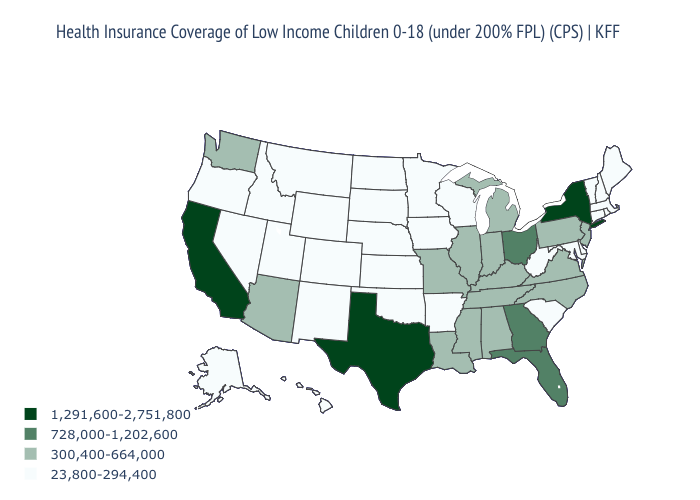Is the legend a continuous bar?
Give a very brief answer. No. What is the value of Wyoming?
Answer briefly. 23,800-294,400. Does Texas have the highest value in the South?
Answer briefly. Yes. Does Texas have the lowest value in the USA?
Concise answer only. No. What is the value of Montana?
Write a very short answer. 23,800-294,400. Does New Hampshire have a higher value than Alabama?
Be succinct. No. Name the states that have a value in the range 300,400-664,000?
Be succinct. Alabama, Arizona, Illinois, Indiana, Kentucky, Louisiana, Michigan, Mississippi, Missouri, New Jersey, North Carolina, Pennsylvania, Tennessee, Virginia, Washington. Name the states that have a value in the range 728,000-1,202,600?
Quick response, please. Florida, Georgia, Ohio. Name the states that have a value in the range 1,291,600-2,751,800?
Write a very short answer. California, New York, Texas. What is the value of Delaware?
Give a very brief answer. 23,800-294,400. Name the states that have a value in the range 23,800-294,400?
Answer briefly. Alaska, Arkansas, Colorado, Connecticut, Delaware, Hawaii, Idaho, Iowa, Kansas, Maine, Maryland, Massachusetts, Minnesota, Montana, Nebraska, Nevada, New Hampshire, New Mexico, North Dakota, Oklahoma, Oregon, Rhode Island, South Carolina, South Dakota, Utah, Vermont, West Virginia, Wisconsin, Wyoming. Name the states that have a value in the range 300,400-664,000?
Write a very short answer. Alabama, Arizona, Illinois, Indiana, Kentucky, Louisiana, Michigan, Mississippi, Missouri, New Jersey, North Carolina, Pennsylvania, Tennessee, Virginia, Washington. Does Virginia have a lower value than California?
Give a very brief answer. Yes. What is the lowest value in the West?
Be succinct. 23,800-294,400. 